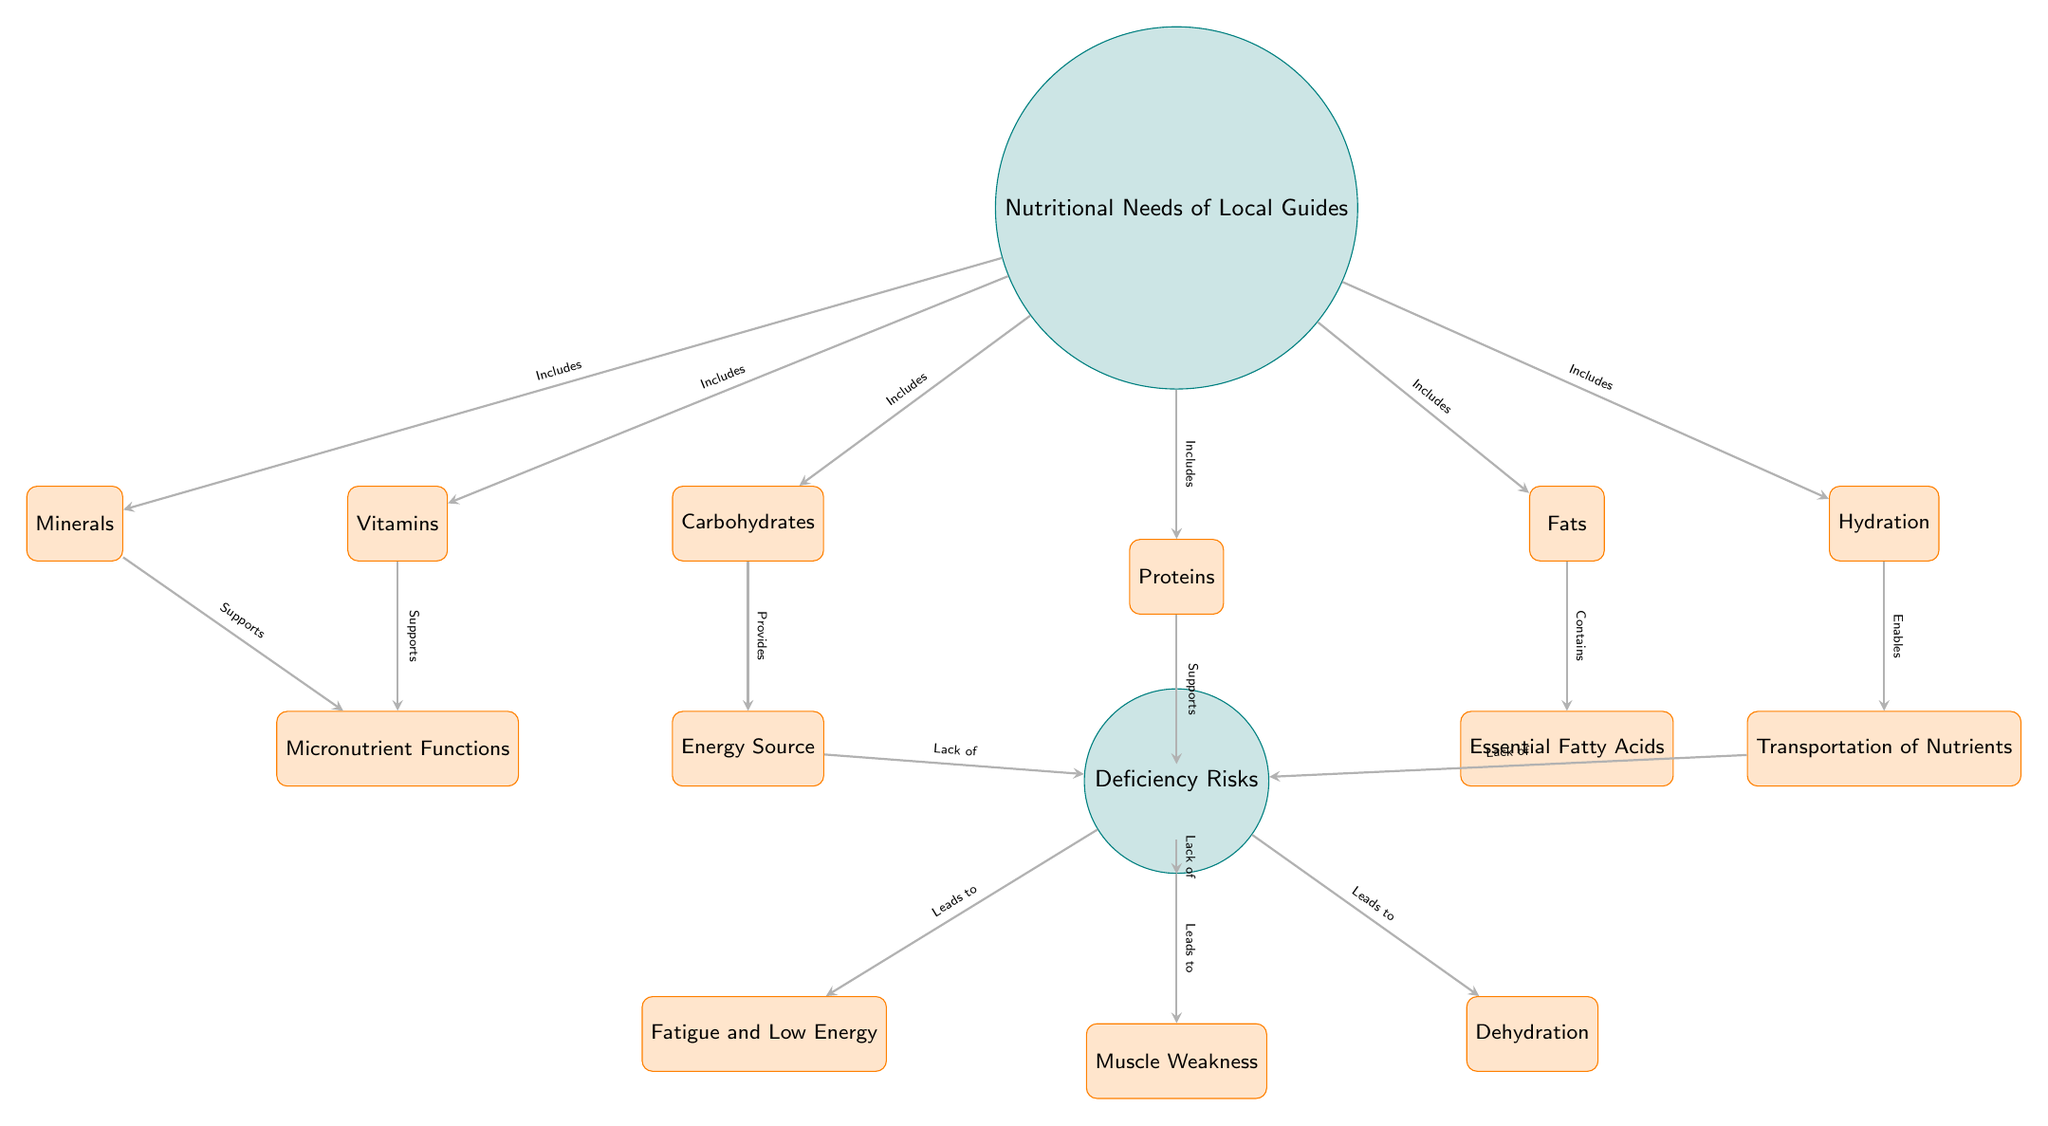What are the main nutritional needs of local guides? Looking at the diagram, there are three main nutritional needs listed: Carbohydrates, Proteins, and Fats. These are positioned directly below the central node "Nutritional Needs of Local Guides."
Answer: Carbohydrates, Proteins, Fats How many deficiency risks are mentioned in the diagram? The diagram shows a main node labeled "Deficiency Risks," which is connected to three risk nodes: Fatigue and Low Energy, Muscle Weakness, and Dehydration. Therefore, there are three mentioned risks.
Answer: 3 What does lack of carbohydrates lead to? The diagram indicates that carbohydrates provide an energy source. The connection from the node "Energy Source" to the deficiency risks shows that lack of carbohydrates leads to Fatigue and Low Energy.
Answer: Fatigue and Low Energy Which node supports muscle repair? The node "Proteins" is directly connected to another node labeled "Muscle Repair," indicating that this is the nutrient that specifically supports muscle repair for local guides.
Answer: Proteins What nutritional component is related to the transportation of nutrients? The diagram lists "Hydration" as a nutrient that enables the transportation of nutrients. This connection is shown in the diagram under the node for hydration and labeled accordingly.
Answer: Hydration What deficiency is caused by lack of hydration? The diagram illustrates that lack of hydration leads to the deficiency risk labeled "Dehydration." This is indicated by the connection between hydration and deficiency risks.
Answer: Dehydration What connections are drawn from the main node "Nutritional Needs of Local Guides"? The main node connects to six secondary nutritional needs: Carbohydrates, Proteins, Fats, Vitamins, Minerals, and Hydration. This shows the various nutritional requirements listed in the diagram.
Answer: 6 connections 